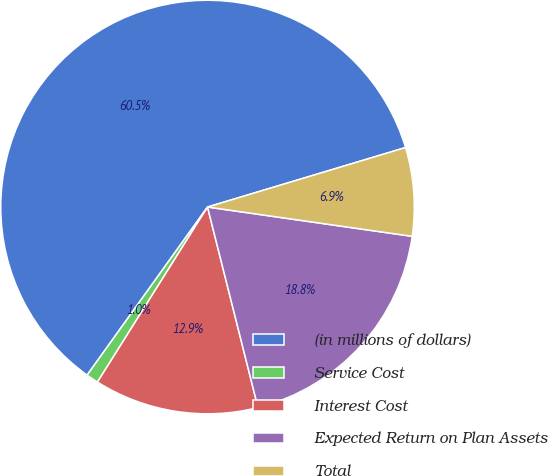Convert chart. <chart><loc_0><loc_0><loc_500><loc_500><pie_chart><fcel>(in millions of dollars)<fcel>Service Cost<fcel>Interest Cost<fcel>Expected Return on Plan Assets<fcel>Total<nl><fcel>60.46%<fcel>0.96%<fcel>12.86%<fcel>18.81%<fcel>6.91%<nl></chart> 